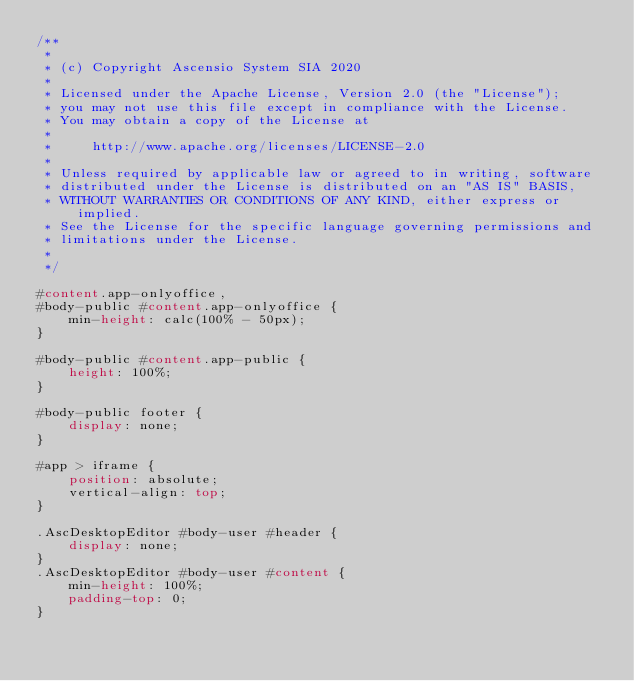Convert code to text. <code><loc_0><loc_0><loc_500><loc_500><_CSS_>/**
 *
 * (c) Copyright Ascensio System SIA 2020
 *
 * Licensed under the Apache License, Version 2.0 (the "License");
 * you may not use this file except in compliance with the License.
 * You may obtain a copy of the License at
 *
 *     http://www.apache.org/licenses/LICENSE-2.0
 *
 * Unless required by applicable law or agreed to in writing, software
 * distributed under the License is distributed on an "AS IS" BASIS,
 * WITHOUT WARRANTIES OR CONDITIONS OF ANY KIND, either express or implied.
 * See the License for the specific language governing permissions and
 * limitations under the License.
 *
 */

#content.app-onlyoffice,
#body-public #content.app-onlyoffice {
    min-height: calc(100% - 50px);
}

#body-public #content.app-public {
    height: 100%;
}

#body-public footer {
    display: none;
}

#app > iframe {
    position: absolute;
    vertical-align: top;
}

.AscDesktopEditor #body-user #header {
    display: none;
}
.AscDesktopEditor #body-user #content {
    min-height: 100%;
    padding-top: 0;
}
</code> 